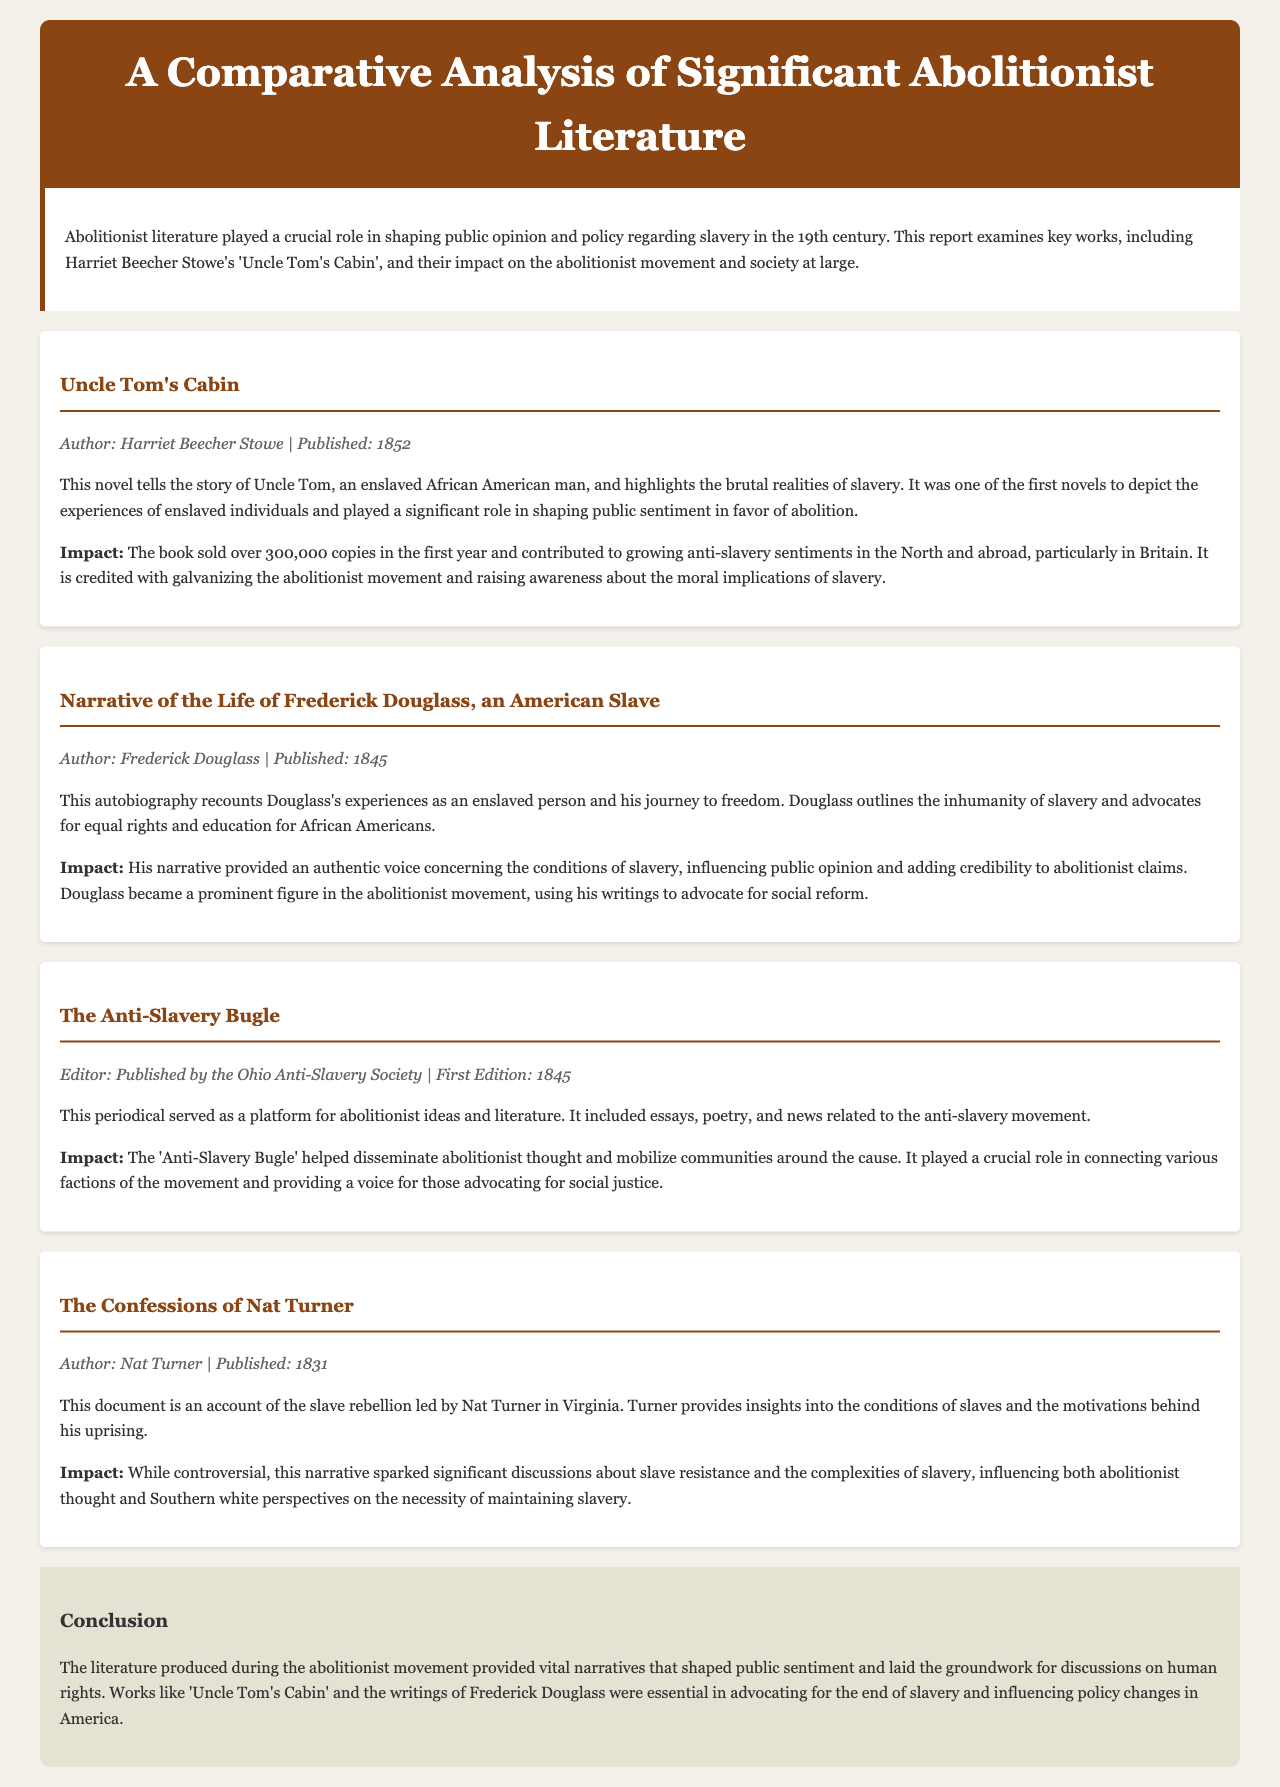What is the title of the report? The title of the report is indicated at the top of the document, which is "A Comparative Analysis of Significant Abolitionist Literature."
Answer: A Comparative Analysis of Significant Abolitionist Literature Who is the author of "Uncle Tom's Cabin"? The document states that Harriet Beecher Stowe is the author of "Uncle Tom's Cabin."
Answer: Harriet Beecher Stowe In what year was "Narrative of the Life of Frederick Douglass, an American Slave" published? The year of publication for "Narrative of the Life of Frederick Douglass, an American Slave" is provided, which is 1845.
Answer: 1845 What was the first edition year of "The Anti-Slavery Bugle"? The document notes that the first edition of "The Anti-Slavery Bugle" was published in 1845.
Answer: 1845 How many copies of "Uncle Tom's Cabin" were sold in the first year? The report mentions that over 300,000 copies of "Uncle Tom's Cabin" were sold in the first year.
Answer: 300,000 What significant impact did "Uncle Tom's Cabin" have on public sentiment? The document describes that "Uncle Tom's Cabin" contributed to growing anti-slavery sentiments in the North and abroad.
Answer: Growing anti-slavery sentiments What is a key theme reflected in Frederick Douglass's narrative? The narrative highlights the inhumanity of slavery and advocates for equal rights.
Answer: Inhumanity of slavery and equal rights What role did "The Anti-Slavery Bugle" play in the movement? The document indicates that "The Anti-Slavery Bugle" helped disseminate abolitionist thought and mobilize communities.
Answer: Disseminate abolitionist thought and mobilize communities Which work provided insight into slave resistance? The document points out that "The Confessions of Nat Turner" provides insights into slave resistance.
Answer: The Confessions of Nat Turner What is the conclusion regarding abolitionist literature's impact? The conclusion states that abolitionist literature shaped public sentiment and influenced policy changes.
Answer: Shaped public sentiment and influenced policy changes 